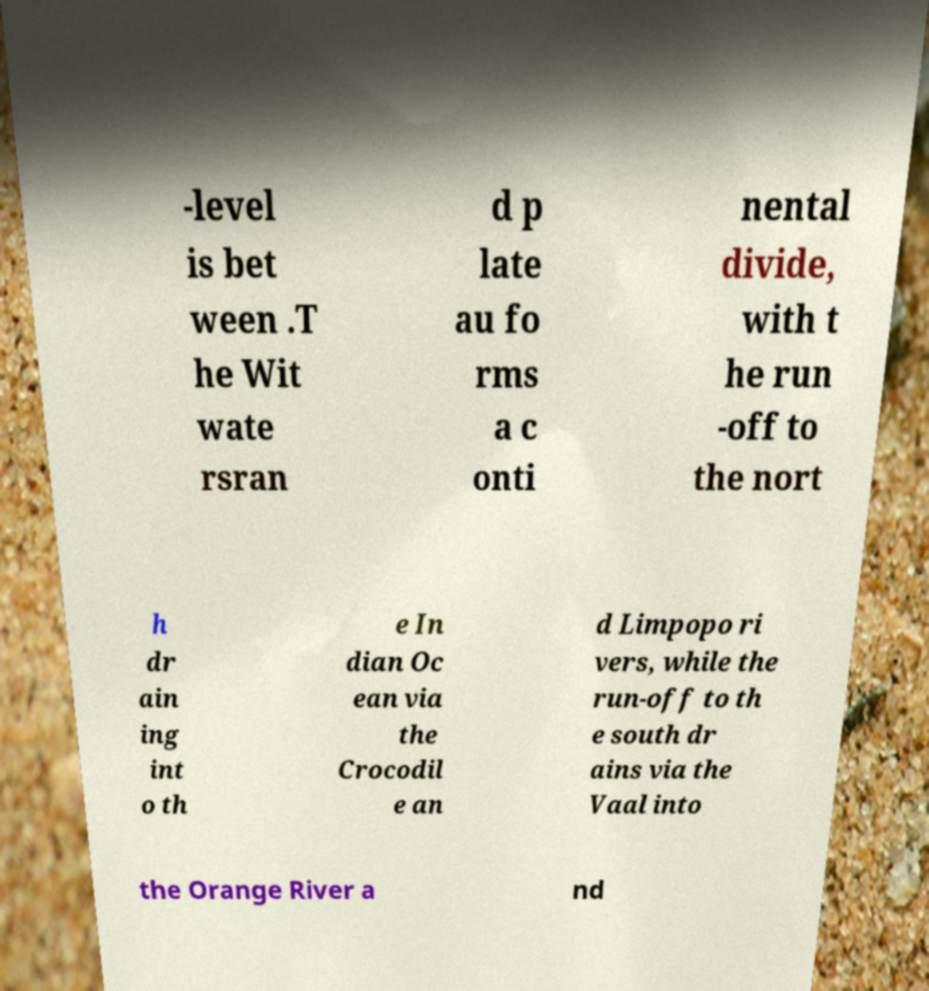What messages or text are displayed in this image? I need them in a readable, typed format. -level is bet ween .T he Wit wate rsran d p late au fo rms a c onti nental divide, with t he run -off to the nort h dr ain ing int o th e In dian Oc ean via the Crocodil e an d Limpopo ri vers, while the run-off to th e south dr ains via the Vaal into the Orange River a nd 